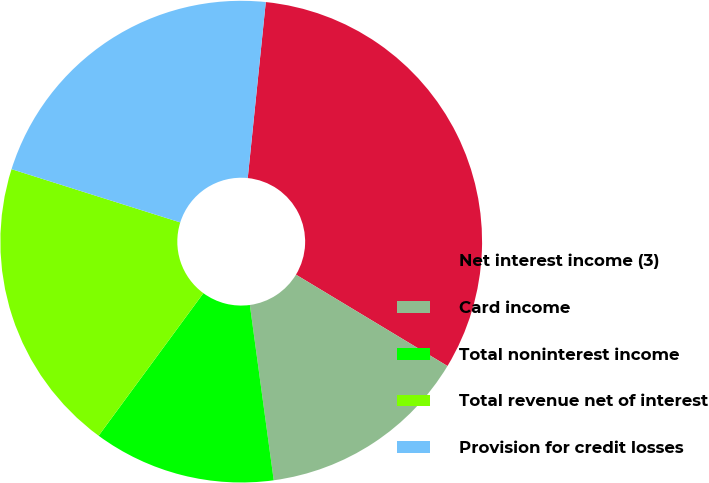<chart> <loc_0><loc_0><loc_500><loc_500><pie_chart><fcel>Net interest income (3)<fcel>Card income<fcel>Total noninterest income<fcel>Total revenue net of interest<fcel>Provision for credit losses<nl><fcel>32.01%<fcel>14.21%<fcel>12.24%<fcel>19.78%<fcel>21.76%<nl></chart> 